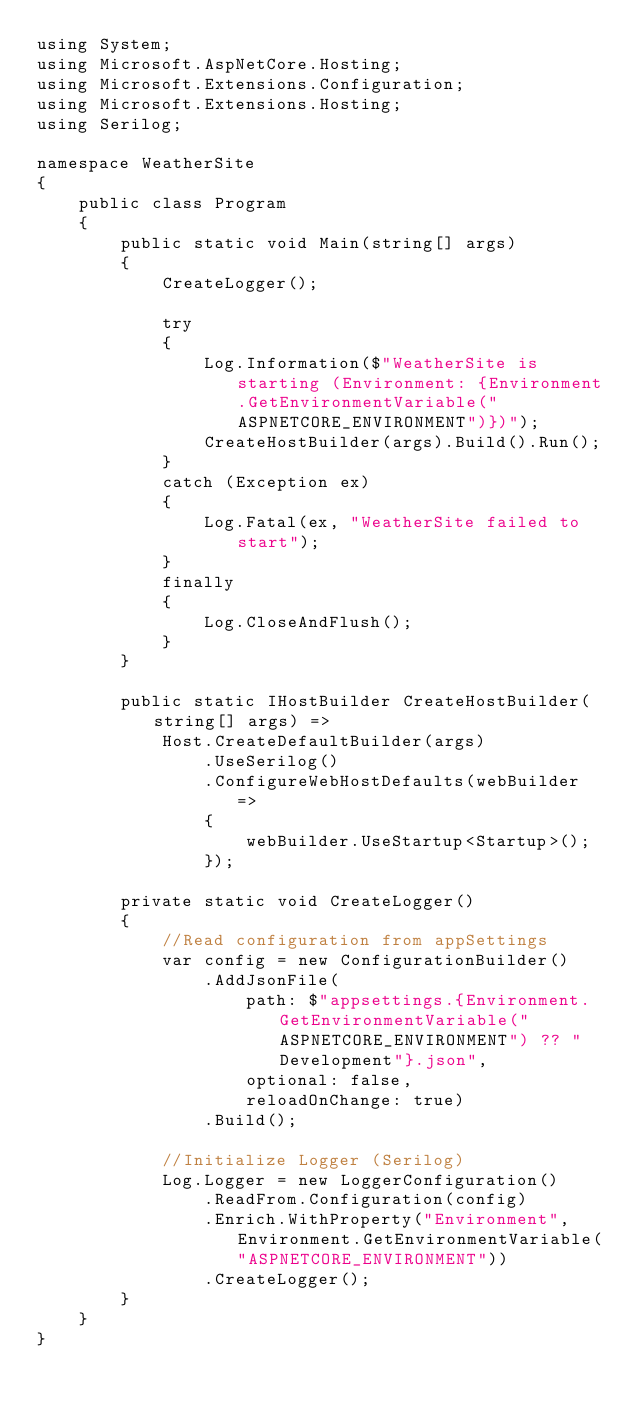<code> <loc_0><loc_0><loc_500><loc_500><_C#_>using System;
using Microsoft.AspNetCore.Hosting;
using Microsoft.Extensions.Configuration;
using Microsoft.Extensions.Hosting;
using Serilog;

namespace WeatherSite
{
    public class Program
    {
        public static void Main(string[] args)
        {
            CreateLogger();

            try
            {
                Log.Information($"WeatherSite is starting (Environment: {Environment.GetEnvironmentVariable("ASPNETCORE_ENVIRONMENT")})");
                CreateHostBuilder(args).Build().Run();
            }
            catch (Exception ex)
            {
                Log.Fatal(ex, "WeatherSite failed to start");
            }
            finally
            {
                Log.CloseAndFlush();
            }
        }

        public static IHostBuilder CreateHostBuilder(string[] args) =>
            Host.CreateDefaultBuilder(args)
                .UseSerilog()
                .ConfigureWebHostDefaults(webBuilder =>
                {
                    webBuilder.UseStartup<Startup>();
                });

        private static void CreateLogger()
        {
            //Read configuration from appSettings
            var config = new ConfigurationBuilder()
                .AddJsonFile(
                    path: $"appsettings.{Environment.GetEnvironmentVariable("ASPNETCORE_ENVIRONMENT") ?? "Development"}.json",
                    optional: false,
                    reloadOnChange: true)
                .Build();

            //Initialize Logger (Serilog)
            Log.Logger = new LoggerConfiguration()
                .ReadFrom.Configuration(config)
                .Enrich.WithProperty("Environment", Environment.GetEnvironmentVariable("ASPNETCORE_ENVIRONMENT"))
                .CreateLogger();
        }
    }
}</code> 